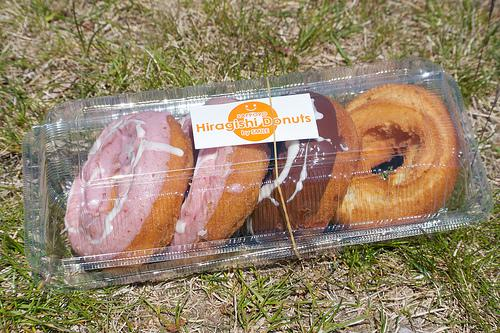Question: how many doughnuts are there?
Choices:
A. One.
B. Two.
C. Four.
D. Three.
Answer with the letter. Answer: C Question: what is in the box?
Choices:
A. Cinnamon rolls.
B. Croissants.
C. Doughnuts.
D. Scones.
Answer with the letter. Answer: C Question: what kind of container?
Choices:
A. Clear plastic.
B. White plastic.
C. Black metal.
D. Blue plastic.
Answer with the letter. Answer: A Question: when is this taken?
Choices:
A. During the day.
B. At night.
C. Early morning.
D. Late evening.
Answer with the letter. Answer: A Question: where is the doughnut box?
Choices:
A. On the table.
B. On the grass.
C. On the bench.
D. On the sidewalk.
Answer with the letter. Answer: B Question: what color is the doughnut on the left?
Choices:
A. Pink.
B. Red.
C. White.
D. Blue.
Answer with the letter. Answer: A Question: what color is the doughnut third from the left?
Choices:
A. Red.
B. Brown.
C. White.
D. Blue.
Answer with the letter. Answer: B 